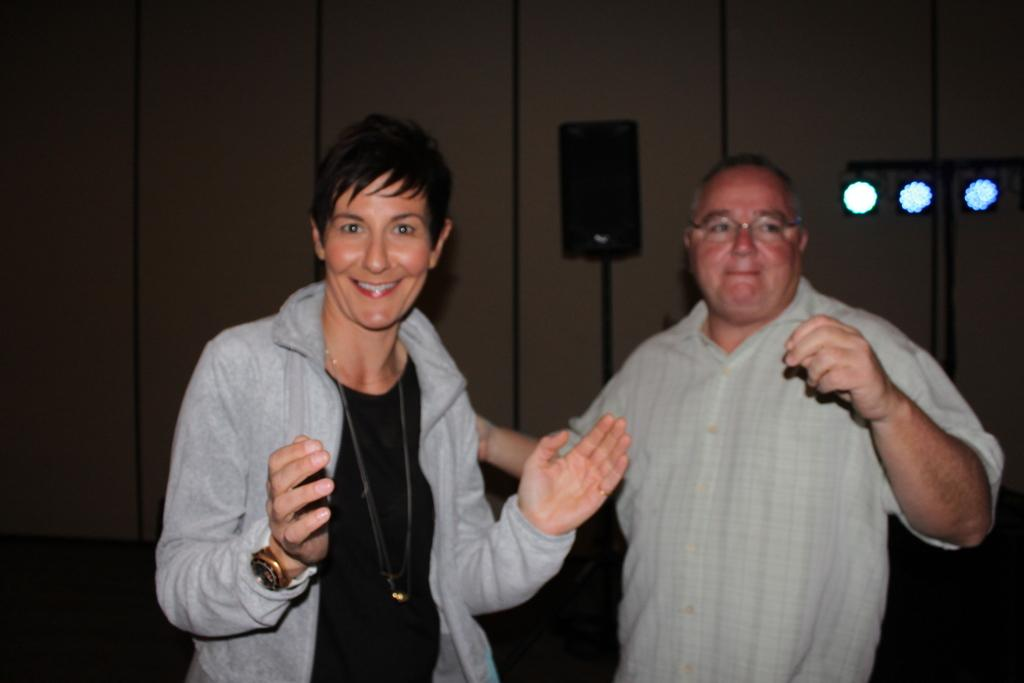How many people are present in the image? There are two people standing in the image. What object can be seen in the image that is typically used for amplifying sound? There is a speaker in the image. What type of illumination is present in the image? There are lights in the image. What can be seen in the background of the image? There is a wall in the background of the image. What type of insurance policy is being discussed by the two people in the image? The image does not provide any information about insurance policies or discussions related to them. 